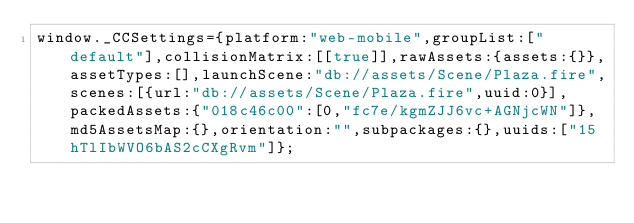<code> <loc_0><loc_0><loc_500><loc_500><_JavaScript_>window._CCSettings={platform:"web-mobile",groupList:["default"],collisionMatrix:[[true]],rawAssets:{assets:{}},assetTypes:[],launchScene:"db://assets/Scene/Plaza.fire",scenes:[{url:"db://assets/Scene/Plaza.fire",uuid:0}],packedAssets:{"018c46c00":[0,"fc7e/kgmZJJ6vc+AGNjcWN"]},md5AssetsMap:{},orientation:"",subpackages:{},uuids:["15hTlIbWVO6bAS2cCXgRvm"]};</code> 